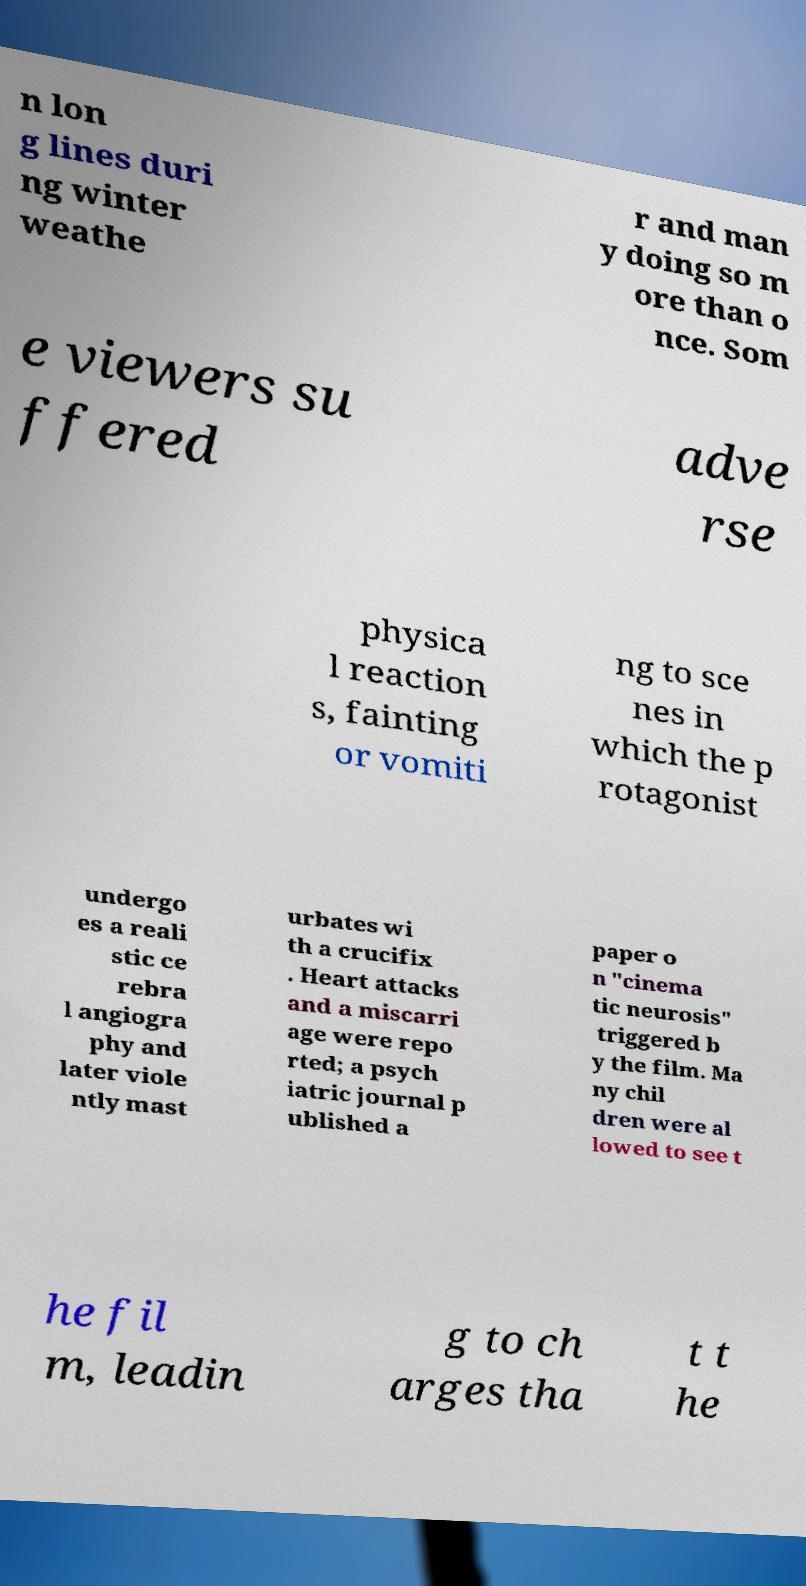What messages or text are displayed in this image? I need them in a readable, typed format. n lon g lines duri ng winter weathe r and man y doing so m ore than o nce. Som e viewers su ffered adve rse physica l reaction s, fainting or vomiti ng to sce nes in which the p rotagonist undergo es a reali stic ce rebra l angiogra phy and later viole ntly mast urbates wi th a crucifix . Heart attacks and a miscarri age were repo rted; a psych iatric journal p ublished a paper o n "cinema tic neurosis" triggered b y the film. Ma ny chil dren were al lowed to see t he fil m, leadin g to ch arges tha t t he 